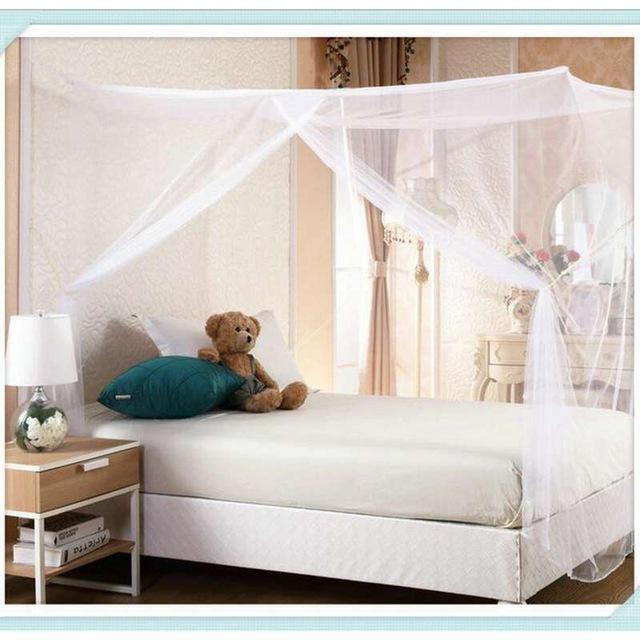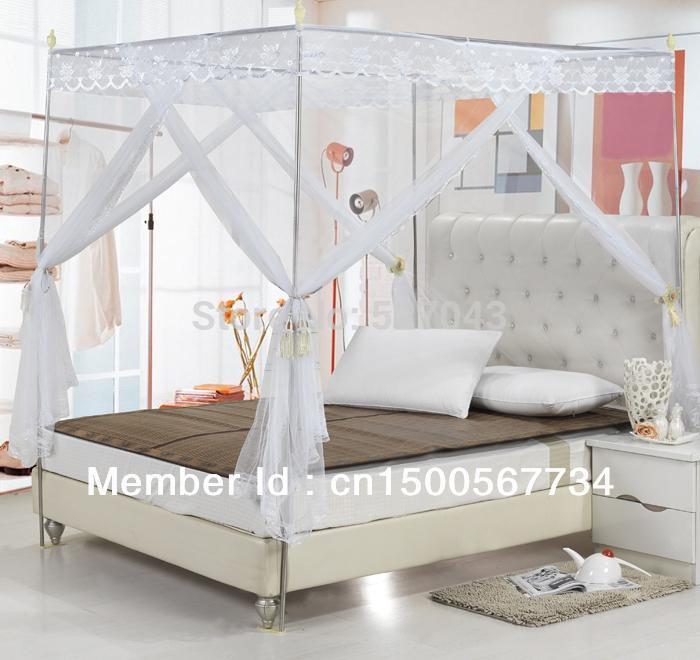The first image is the image on the left, the second image is the image on the right. Assess this claim about the two images: "There is a stuffed animal on top of one of the beds.". Correct or not? Answer yes or no. Yes. The first image is the image on the left, the second image is the image on the right. Examine the images to the left and right. Is the description "There is a stuffed toy resting on one of the beds." accurate? Answer yes or no. Yes. 